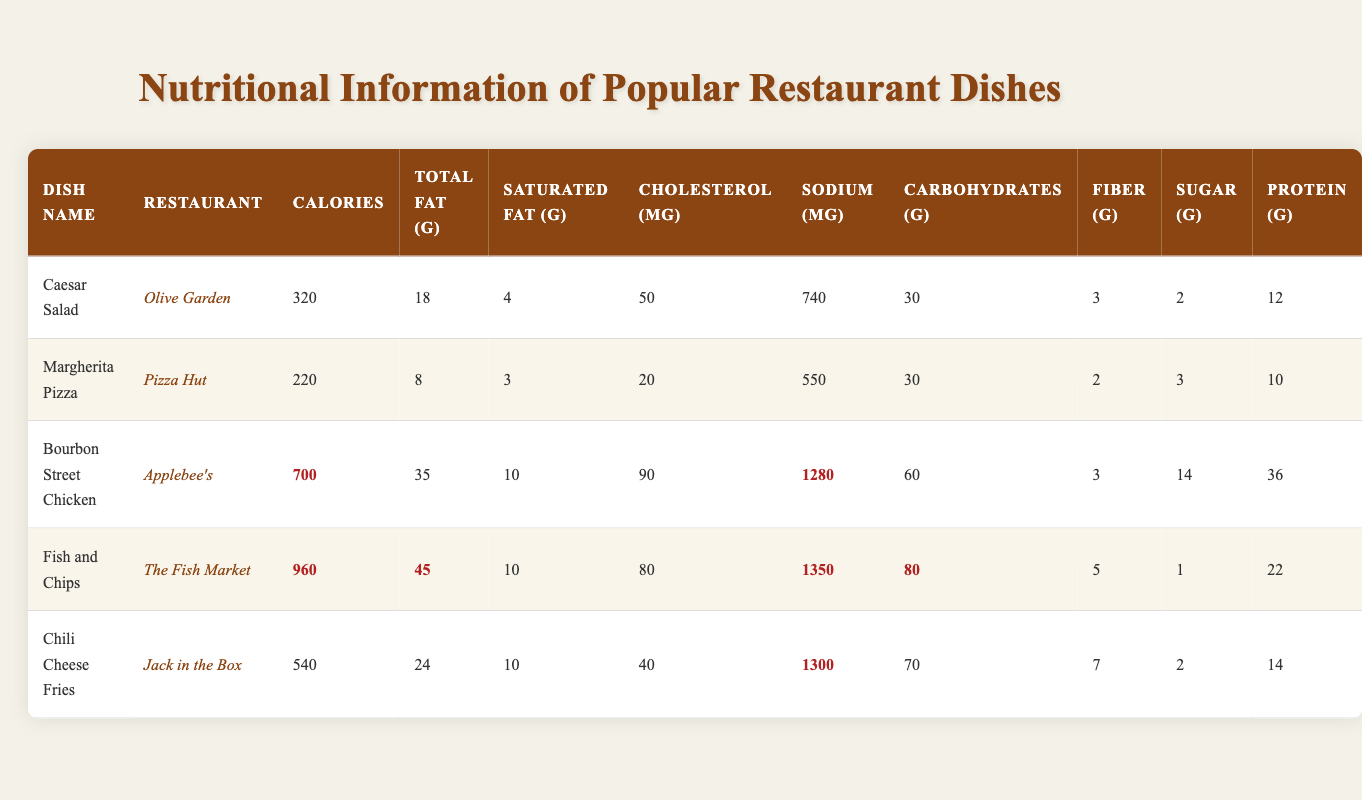What is the highest calorie dish on the table? By looking across the "Calories" column, the highest value is listed next to "Fish and Chips" with 960 calories.
Answer: 960 Which dish has the lowest amount of total fat? Scanning the "Total Fat (g)" column, the lowest value is 8 grams, which is associated with "Margherita Pizza."
Answer: 8 How many grams of protein does the "Bourbon Street Chicken" contain? The "Protein (g)" column for "Bourbon Street Chicken" shows a value of 36 grams.
Answer: 36 Is the cholesterol content in "Caesar Salad" greater than that in "Margherita Pizza"? The "Cholesterol (mg)" for "Caesar Salad" is 50 mg, and for "Margherita Pizza" it is 20 mg. Since 50 is greater than 20, the statement is true.
Answer: Yes What is the difference in sodium content between "Chili Cheese Fries" and "Fish and Chips"? The sodium for "Chili Cheese Fries" is 1300 mg, and for "Fish and Chips," it is 1350 mg. Subtracting gives 1350 - 1300 = 50 mg difference.
Answer: 50 What is the average calorie content of the dishes in this table? The total calories are 320 + 220 + 700 + 960 + 540 = 2740. There are 5 dishes, so the average is 2740 / 5 = 548.
Answer: 548 Which dish has more fiber, "Caesar Salad" or "Fish and Chips"? Looking at the "Fiber (g)" column, "Caesar Salad" has 3 grams and "Fish and Chips" has 5 grams. Since 5 is greater than 3, "Fish and Chips" has more fiber.
Answer: Fish and Chips Is the total fat content of "Chili Cheese Fries" higher than that of "Bourbon Street Chicken"? "Chili Cheese Fries" contains 24 grams of total fat, and "Bourbon Street Chicken" has 35 grams. Since 24 is less than 35, the statement is false.
Answer: No What is the sum of carbohydrates in "Margherita Pizza" and "Fish and Chips"? The carbohydrate content for "Margherita Pizza" is 30 grams and for "Fish and Chips" it is 80 grams. Adding these gives 30 + 80 = 110 grams.
Answer: 110 